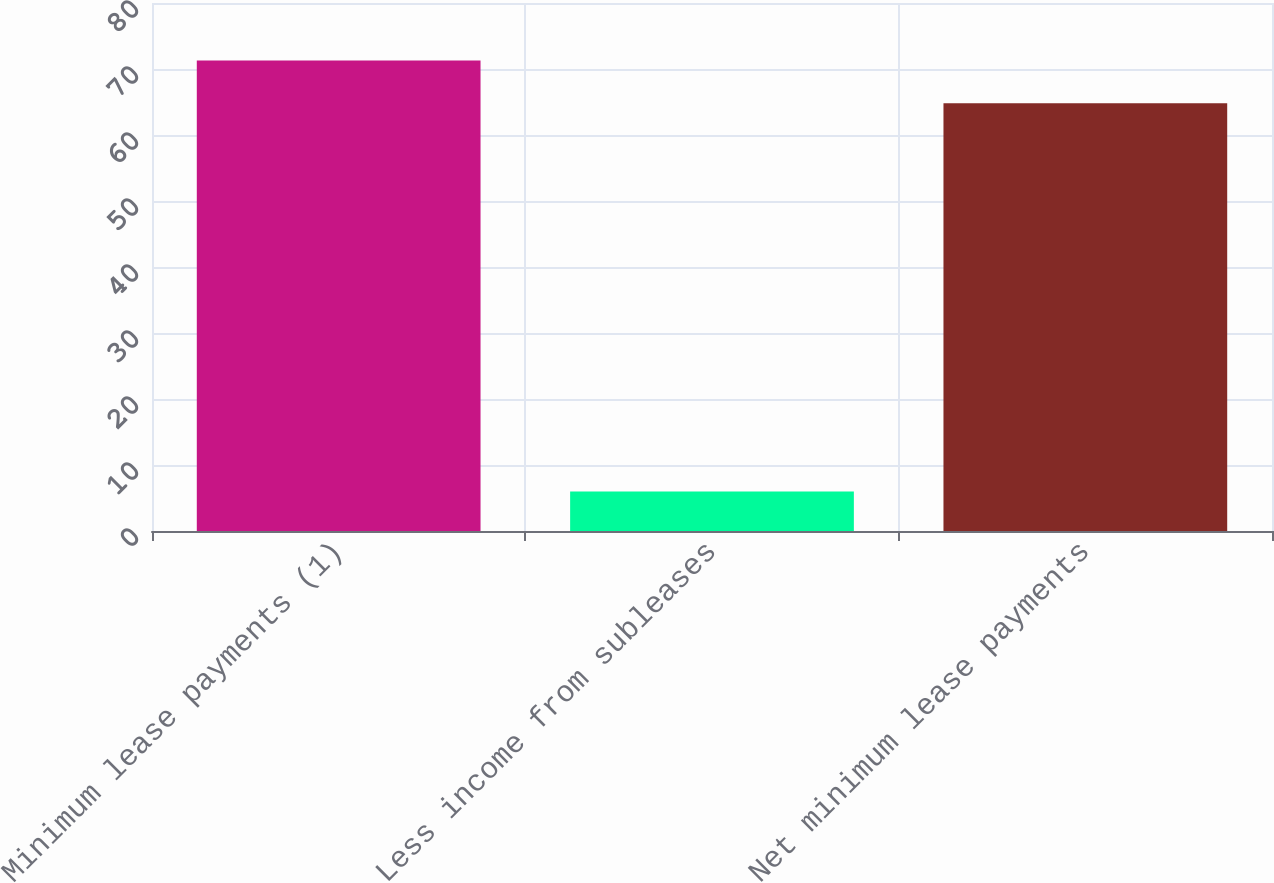Convert chart to OTSL. <chart><loc_0><loc_0><loc_500><loc_500><bar_chart><fcel>Minimum lease payments (1)<fcel>Less income from subleases<fcel>Net minimum lease payments<nl><fcel>71.28<fcel>6<fcel>64.8<nl></chart> 